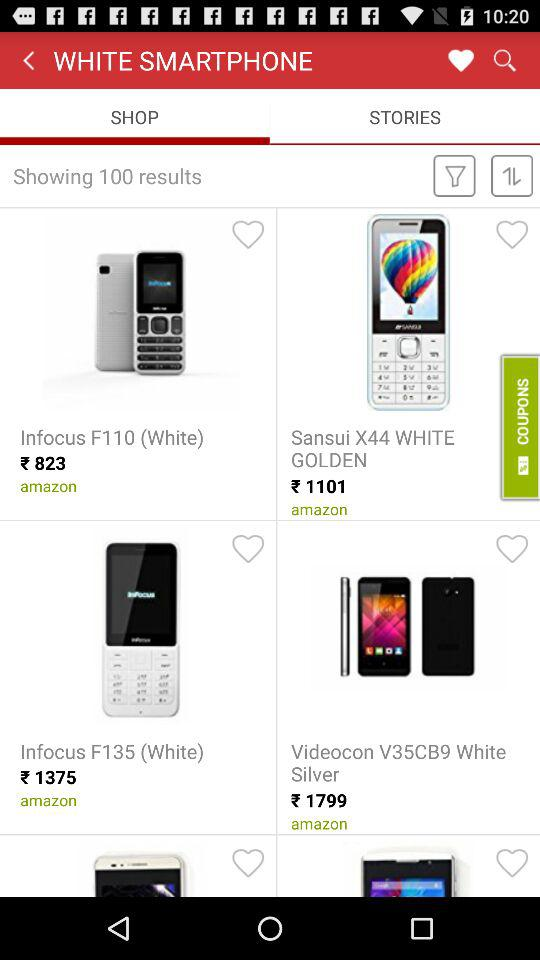How many results are shown?
Answer the question using a single word or phrase. 100 